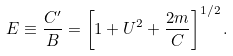<formula> <loc_0><loc_0><loc_500><loc_500>E \equiv \frac { C ^ { \prime } } { B } = \left [ 1 + U ^ { 2 } + \frac { 2 m } { C } \right ] ^ { 1 / 2 } .</formula> 